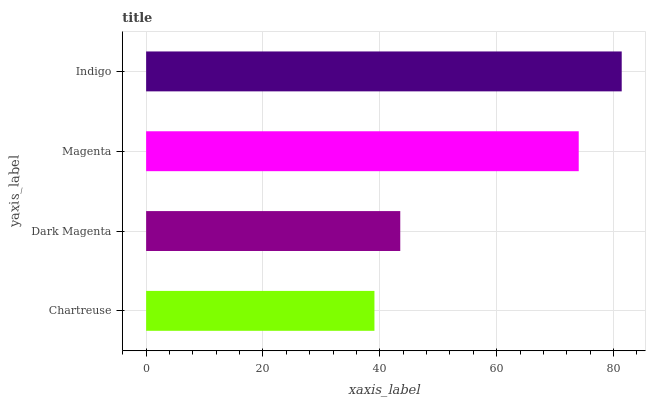Is Chartreuse the minimum?
Answer yes or no. Yes. Is Indigo the maximum?
Answer yes or no. Yes. Is Dark Magenta the minimum?
Answer yes or no. No. Is Dark Magenta the maximum?
Answer yes or no. No. Is Dark Magenta greater than Chartreuse?
Answer yes or no. Yes. Is Chartreuse less than Dark Magenta?
Answer yes or no. Yes. Is Chartreuse greater than Dark Magenta?
Answer yes or no. No. Is Dark Magenta less than Chartreuse?
Answer yes or no. No. Is Magenta the high median?
Answer yes or no. Yes. Is Dark Magenta the low median?
Answer yes or no. Yes. Is Indigo the high median?
Answer yes or no. No. Is Magenta the low median?
Answer yes or no. No. 